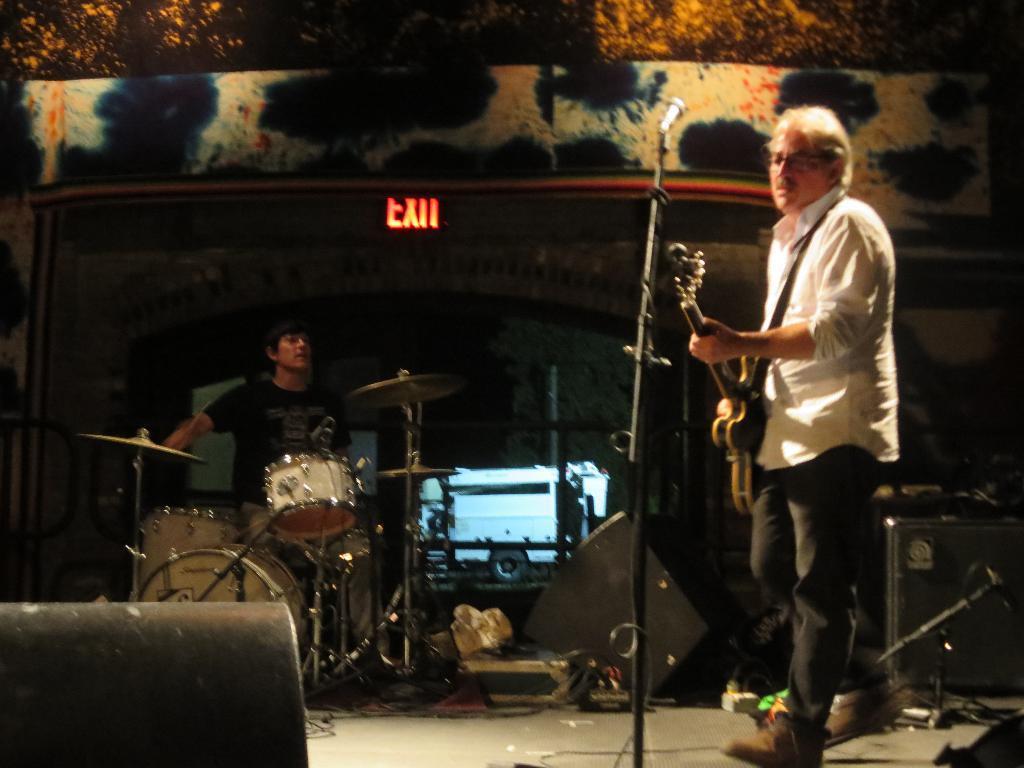Describe this image in one or two sentences. In the picture a man is standing in front of a mic by holding a guitar and beside him there is some other person playing instruments. 